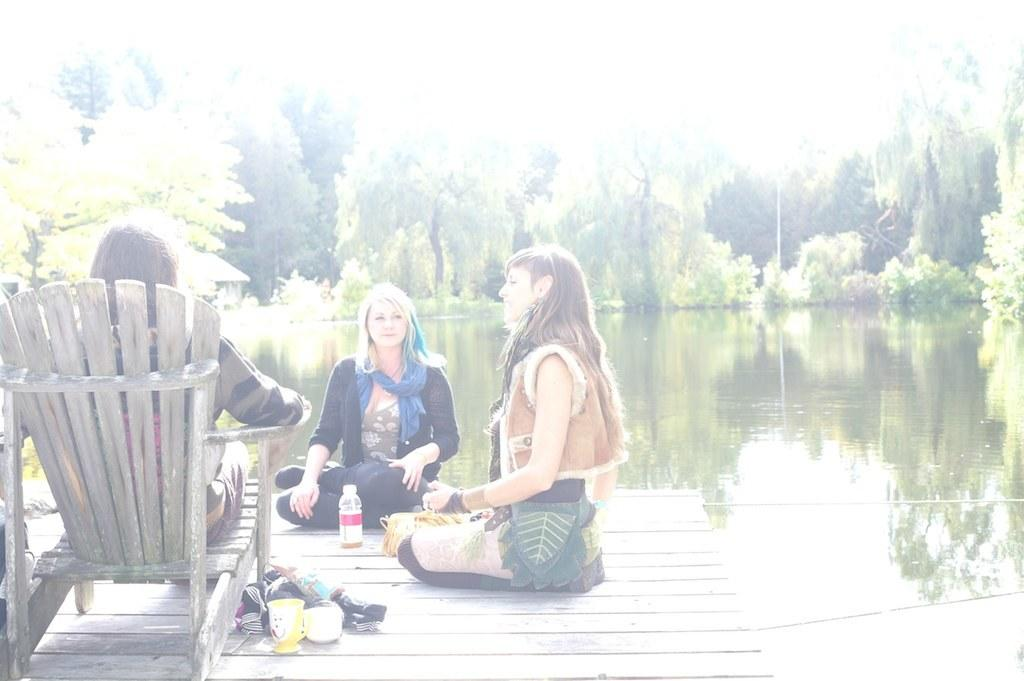What is the person in the image doing? The person in the image is sitting on a chair. Can you describe the person's gender? The person is a woman. What type of clothing is the woman wearing? The woman is wearing a sweater and a shirt. What is the woman's facial expression? The woman is smiling. What book is the woman reading in the image? There is no book present in the image; the woman is simply sitting on a chair and smiling. 